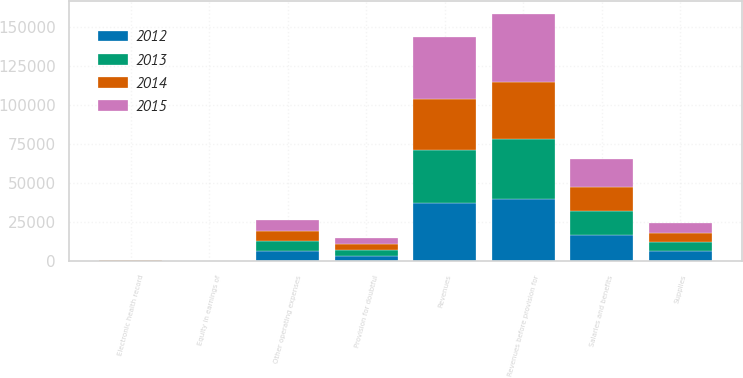<chart> <loc_0><loc_0><loc_500><loc_500><stacked_bar_chart><ecel><fcel>Revenues before provision for<fcel>Provision for doubtful<fcel>Revenues<fcel>Salaries and benefits<fcel>Supplies<fcel>Other operating expenses<fcel>Electronic health record<fcel>Equity in earnings of<nl><fcel>2015<fcel>43591<fcel>3913<fcel>39678<fcel>18115<fcel>6638<fcel>7103<fcel>47<fcel>46<nl><fcel>2012<fcel>40087<fcel>3169<fcel>36918<fcel>16641<fcel>6262<fcel>6755<fcel>125<fcel>43<nl><fcel>2013<fcel>38040<fcel>3858<fcel>34182<fcel>15646<fcel>5970<fcel>6237<fcel>216<fcel>29<nl><fcel>2014<fcel>36783<fcel>3770<fcel>33013<fcel>15089<fcel>5717<fcel>6048<fcel>336<fcel>36<nl></chart> 